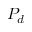<formula> <loc_0><loc_0><loc_500><loc_500>P _ { d }</formula> 